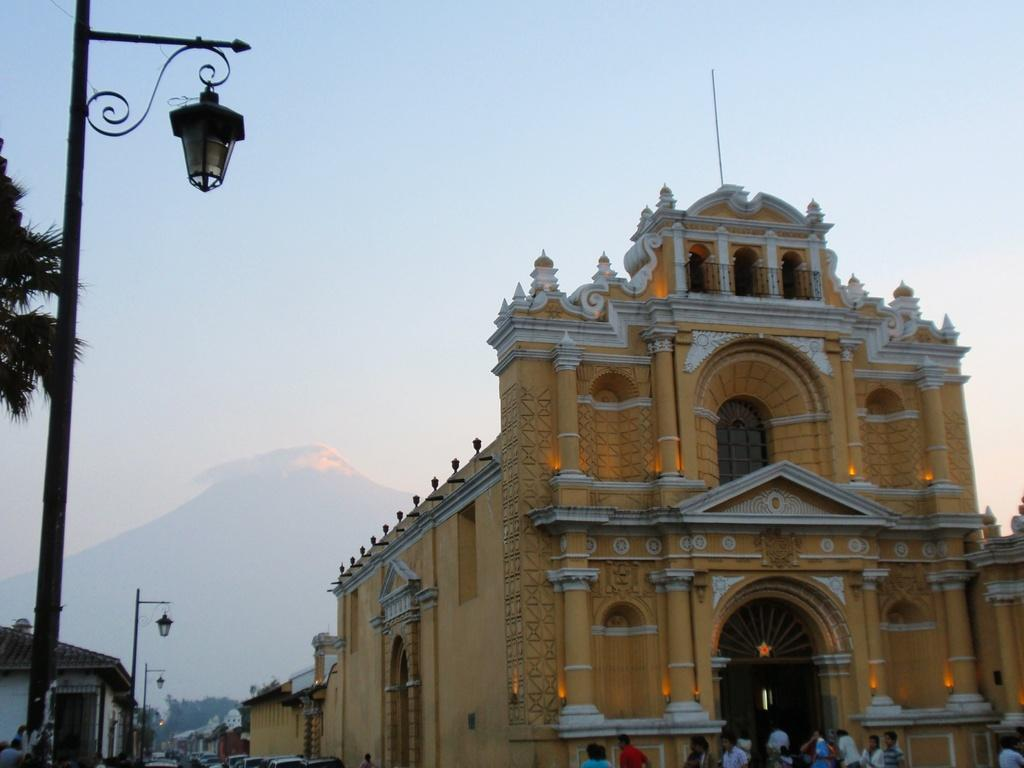What can be found on the left side of the image? There are street lights, trees, and buildings on the left side of the image. What is located in the center of the image? There are buildings and people in the center of the image. What is visible in the background of the image? There is a mountain visible in the background of the image. What color of paint is being used by the fact in the image? There is no fact or paint present in the image. Where can someone find a seat in the image? There is no seat visible in the image. 